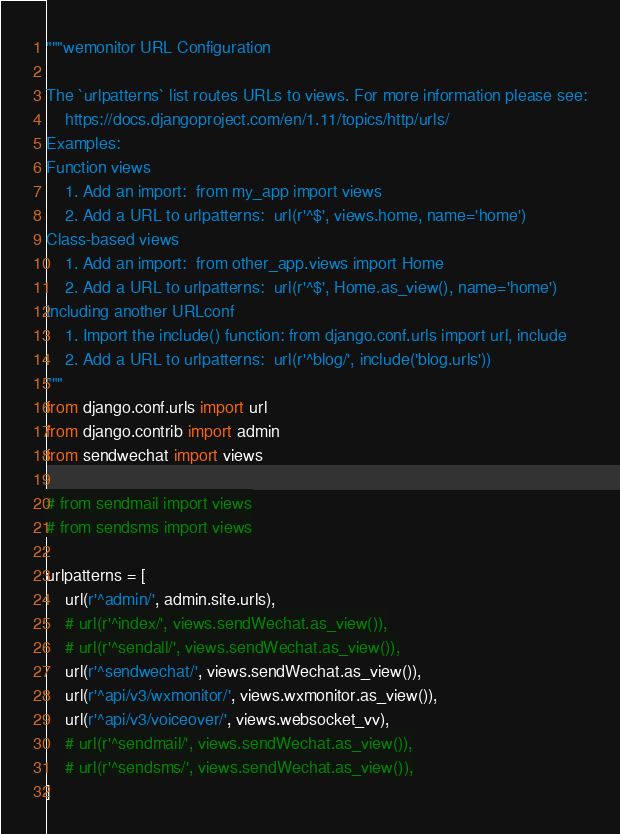<code> <loc_0><loc_0><loc_500><loc_500><_Python_>"""wemonitor URL Configuration

The `urlpatterns` list routes URLs to views. For more information please see:
    https://docs.djangoproject.com/en/1.11/topics/http/urls/
Examples:
Function views
    1. Add an import:  from my_app import views
    2. Add a URL to urlpatterns:  url(r'^$', views.home, name='home')
Class-based views
    1. Add an import:  from other_app.views import Home
    2. Add a URL to urlpatterns:  url(r'^$', Home.as_view(), name='home')
Including another URLconf
    1. Import the include() function: from django.conf.urls import url, include
    2. Add a URL to urlpatterns:  url(r'^blog/', include('blog.urls'))
"""
from django.conf.urls import url
from django.contrib import admin
from sendwechat import views

# from sendmail import views
# from sendsms import views

urlpatterns = [
    url(r'^admin/', admin.site.urls),
    # url(r'^index/', views.sendWechat.as_view()),
    # url(r'^sendall/', views.sendWechat.as_view()),
    url(r'^sendwechat/', views.sendWechat.as_view()),
    url(r'^api/v3/wxmonitor/', views.wxmonitor.as_view()),
    url(r'^api/v3/voiceover/', views.websocket_vv),
    # url(r'^sendmail/', views.sendWechat.as_view()),
    # url(r'^sendsms/', views.sendWechat.as_view()),
]
</code> 